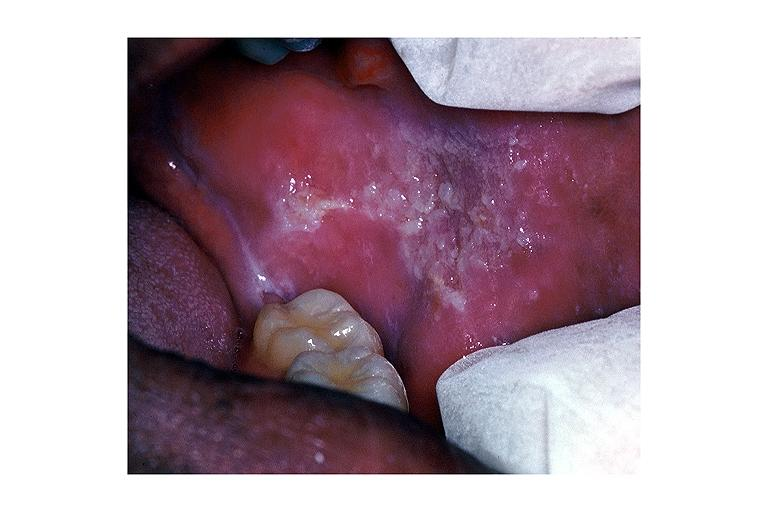where is this?
Answer the question using a single word or phrase. Oral 